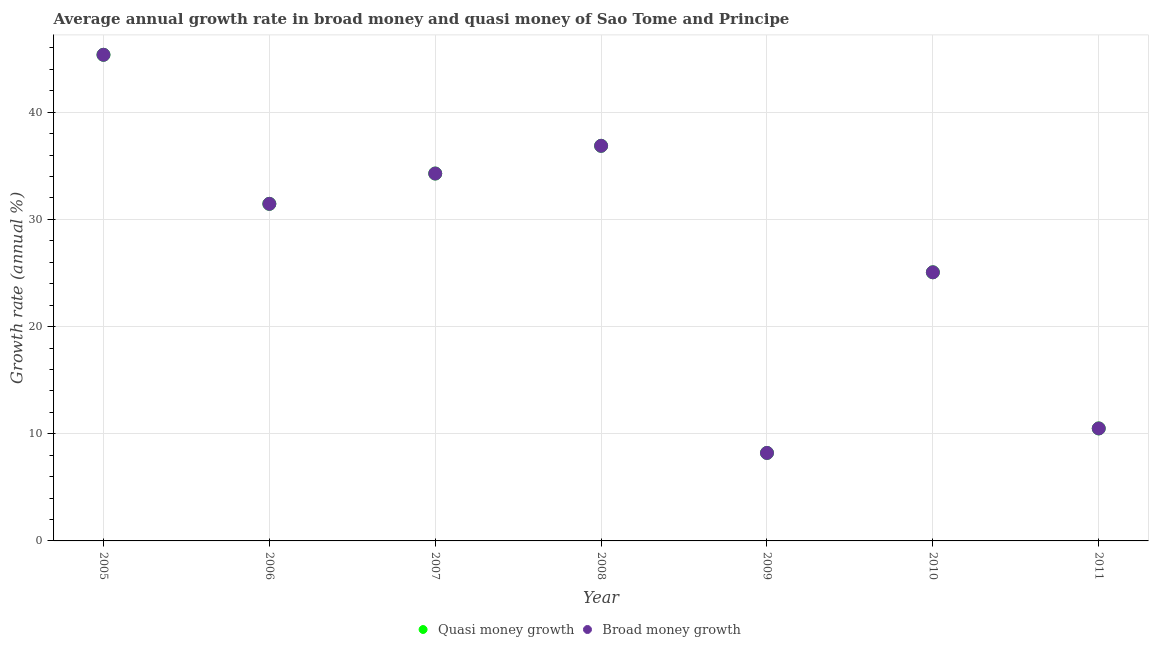Is the number of dotlines equal to the number of legend labels?
Provide a short and direct response. Yes. What is the annual growth rate in broad money in 2008?
Give a very brief answer. 36.87. Across all years, what is the maximum annual growth rate in broad money?
Keep it short and to the point. 45.36. Across all years, what is the minimum annual growth rate in quasi money?
Ensure brevity in your answer.  8.21. What is the total annual growth rate in quasi money in the graph?
Keep it short and to the point. 191.73. What is the difference between the annual growth rate in quasi money in 2006 and that in 2007?
Your answer should be very brief. -2.83. What is the difference between the annual growth rate in quasi money in 2009 and the annual growth rate in broad money in 2008?
Offer a terse response. -28.66. What is the average annual growth rate in broad money per year?
Ensure brevity in your answer.  27.39. In the year 2011, what is the difference between the annual growth rate in broad money and annual growth rate in quasi money?
Provide a short and direct response. 0. What is the ratio of the annual growth rate in broad money in 2005 to that in 2010?
Ensure brevity in your answer.  1.81. Is the difference between the annual growth rate in broad money in 2008 and 2011 greater than the difference between the annual growth rate in quasi money in 2008 and 2011?
Your answer should be very brief. No. What is the difference between the highest and the second highest annual growth rate in broad money?
Ensure brevity in your answer.  8.49. What is the difference between the highest and the lowest annual growth rate in quasi money?
Ensure brevity in your answer.  37.15. In how many years, is the annual growth rate in broad money greater than the average annual growth rate in broad money taken over all years?
Your response must be concise. 4. Is the sum of the annual growth rate in broad money in 2007 and 2011 greater than the maximum annual growth rate in quasi money across all years?
Give a very brief answer. No. Is the annual growth rate in broad money strictly less than the annual growth rate in quasi money over the years?
Provide a succinct answer. No. How many dotlines are there?
Offer a terse response. 2. How many years are there in the graph?
Offer a terse response. 7. What is the difference between two consecutive major ticks on the Y-axis?
Make the answer very short. 10. Does the graph contain any zero values?
Provide a succinct answer. No. How many legend labels are there?
Your answer should be very brief. 2. What is the title of the graph?
Provide a short and direct response. Average annual growth rate in broad money and quasi money of Sao Tome and Principe. Does "Measles" appear as one of the legend labels in the graph?
Your response must be concise. No. What is the label or title of the X-axis?
Make the answer very short. Year. What is the label or title of the Y-axis?
Provide a succinct answer. Growth rate (annual %). What is the Growth rate (annual %) in Quasi money growth in 2005?
Your answer should be compact. 45.36. What is the Growth rate (annual %) in Broad money growth in 2005?
Ensure brevity in your answer.  45.36. What is the Growth rate (annual %) of Quasi money growth in 2006?
Provide a short and direct response. 31.45. What is the Growth rate (annual %) in Broad money growth in 2006?
Your response must be concise. 31.45. What is the Growth rate (annual %) in Quasi money growth in 2007?
Your answer should be very brief. 34.28. What is the Growth rate (annual %) of Broad money growth in 2007?
Offer a very short reply. 34.28. What is the Growth rate (annual %) of Quasi money growth in 2008?
Offer a very short reply. 36.87. What is the Growth rate (annual %) of Broad money growth in 2008?
Your response must be concise. 36.87. What is the Growth rate (annual %) in Quasi money growth in 2009?
Provide a short and direct response. 8.21. What is the Growth rate (annual %) of Broad money growth in 2009?
Offer a very short reply. 8.21. What is the Growth rate (annual %) of Quasi money growth in 2010?
Give a very brief answer. 25.06. What is the Growth rate (annual %) of Broad money growth in 2010?
Your answer should be very brief. 25.06. What is the Growth rate (annual %) of Quasi money growth in 2011?
Ensure brevity in your answer.  10.5. What is the Growth rate (annual %) of Broad money growth in 2011?
Your answer should be very brief. 10.5. Across all years, what is the maximum Growth rate (annual %) in Quasi money growth?
Provide a succinct answer. 45.36. Across all years, what is the maximum Growth rate (annual %) in Broad money growth?
Give a very brief answer. 45.36. Across all years, what is the minimum Growth rate (annual %) of Quasi money growth?
Provide a short and direct response. 8.21. Across all years, what is the minimum Growth rate (annual %) in Broad money growth?
Offer a very short reply. 8.21. What is the total Growth rate (annual %) of Quasi money growth in the graph?
Provide a succinct answer. 191.73. What is the total Growth rate (annual %) in Broad money growth in the graph?
Provide a short and direct response. 191.73. What is the difference between the Growth rate (annual %) of Quasi money growth in 2005 and that in 2006?
Your response must be concise. 13.91. What is the difference between the Growth rate (annual %) of Broad money growth in 2005 and that in 2006?
Provide a short and direct response. 13.91. What is the difference between the Growth rate (annual %) of Quasi money growth in 2005 and that in 2007?
Keep it short and to the point. 11.08. What is the difference between the Growth rate (annual %) in Broad money growth in 2005 and that in 2007?
Your answer should be compact. 11.08. What is the difference between the Growth rate (annual %) of Quasi money growth in 2005 and that in 2008?
Your answer should be very brief. 8.49. What is the difference between the Growth rate (annual %) in Broad money growth in 2005 and that in 2008?
Your response must be concise. 8.49. What is the difference between the Growth rate (annual %) of Quasi money growth in 2005 and that in 2009?
Offer a terse response. 37.15. What is the difference between the Growth rate (annual %) in Broad money growth in 2005 and that in 2009?
Your response must be concise. 37.15. What is the difference between the Growth rate (annual %) in Quasi money growth in 2005 and that in 2010?
Provide a short and direct response. 20.3. What is the difference between the Growth rate (annual %) of Broad money growth in 2005 and that in 2010?
Offer a terse response. 20.3. What is the difference between the Growth rate (annual %) of Quasi money growth in 2005 and that in 2011?
Your answer should be compact. 34.86. What is the difference between the Growth rate (annual %) in Broad money growth in 2005 and that in 2011?
Keep it short and to the point. 34.86. What is the difference between the Growth rate (annual %) in Quasi money growth in 2006 and that in 2007?
Give a very brief answer. -2.83. What is the difference between the Growth rate (annual %) in Broad money growth in 2006 and that in 2007?
Your response must be concise. -2.83. What is the difference between the Growth rate (annual %) in Quasi money growth in 2006 and that in 2008?
Ensure brevity in your answer.  -5.42. What is the difference between the Growth rate (annual %) in Broad money growth in 2006 and that in 2008?
Your answer should be very brief. -5.42. What is the difference between the Growth rate (annual %) in Quasi money growth in 2006 and that in 2009?
Your answer should be very brief. 23.24. What is the difference between the Growth rate (annual %) in Broad money growth in 2006 and that in 2009?
Keep it short and to the point. 23.24. What is the difference between the Growth rate (annual %) of Quasi money growth in 2006 and that in 2010?
Ensure brevity in your answer.  6.39. What is the difference between the Growth rate (annual %) in Broad money growth in 2006 and that in 2010?
Ensure brevity in your answer.  6.39. What is the difference between the Growth rate (annual %) in Quasi money growth in 2006 and that in 2011?
Give a very brief answer. 20.95. What is the difference between the Growth rate (annual %) in Broad money growth in 2006 and that in 2011?
Give a very brief answer. 20.95. What is the difference between the Growth rate (annual %) of Quasi money growth in 2007 and that in 2008?
Your answer should be compact. -2.59. What is the difference between the Growth rate (annual %) in Broad money growth in 2007 and that in 2008?
Your answer should be very brief. -2.59. What is the difference between the Growth rate (annual %) in Quasi money growth in 2007 and that in 2009?
Make the answer very short. 26.07. What is the difference between the Growth rate (annual %) of Broad money growth in 2007 and that in 2009?
Offer a very short reply. 26.07. What is the difference between the Growth rate (annual %) of Quasi money growth in 2007 and that in 2010?
Offer a terse response. 9.22. What is the difference between the Growth rate (annual %) of Broad money growth in 2007 and that in 2010?
Your answer should be compact. 9.22. What is the difference between the Growth rate (annual %) in Quasi money growth in 2007 and that in 2011?
Provide a succinct answer. 23.78. What is the difference between the Growth rate (annual %) in Broad money growth in 2007 and that in 2011?
Your answer should be very brief. 23.78. What is the difference between the Growth rate (annual %) of Quasi money growth in 2008 and that in 2009?
Provide a short and direct response. 28.66. What is the difference between the Growth rate (annual %) of Broad money growth in 2008 and that in 2009?
Offer a terse response. 28.66. What is the difference between the Growth rate (annual %) of Quasi money growth in 2008 and that in 2010?
Provide a succinct answer. 11.8. What is the difference between the Growth rate (annual %) of Broad money growth in 2008 and that in 2010?
Ensure brevity in your answer.  11.8. What is the difference between the Growth rate (annual %) in Quasi money growth in 2008 and that in 2011?
Your answer should be compact. 26.37. What is the difference between the Growth rate (annual %) of Broad money growth in 2008 and that in 2011?
Your answer should be very brief. 26.37. What is the difference between the Growth rate (annual %) of Quasi money growth in 2009 and that in 2010?
Your answer should be compact. -16.86. What is the difference between the Growth rate (annual %) in Broad money growth in 2009 and that in 2010?
Your answer should be very brief. -16.86. What is the difference between the Growth rate (annual %) in Quasi money growth in 2009 and that in 2011?
Make the answer very short. -2.29. What is the difference between the Growth rate (annual %) in Broad money growth in 2009 and that in 2011?
Your answer should be very brief. -2.29. What is the difference between the Growth rate (annual %) in Quasi money growth in 2010 and that in 2011?
Give a very brief answer. 14.57. What is the difference between the Growth rate (annual %) of Broad money growth in 2010 and that in 2011?
Provide a short and direct response. 14.57. What is the difference between the Growth rate (annual %) in Quasi money growth in 2005 and the Growth rate (annual %) in Broad money growth in 2006?
Your answer should be compact. 13.91. What is the difference between the Growth rate (annual %) in Quasi money growth in 2005 and the Growth rate (annual %) in Broad money growth in 2007?
Provide a succinct answer. 11.08. What is the difference between the Growth rate (annual %) of Quasi money growth in 2005 and the Growth rate (annual %) of Broad money growth in 2008?
Make the answer very short. 8.49. What is the difference between the Growth rate (annual %) in Quasi money growth in 2005 and the Growth rate (annual %) in Broad money growth in 2009?
Make the answer very short. 37.15. What is the difference between the Growth rate (annual %) in Quasi money growth in 2005 and the Growth rate (annual %) in Broad money growth in 2010?
Keep it short and to the point. 20.3. What is the difference between the Growth rate (annual %) in Quasi money growth in 2005 and the Growth rate (annual %) in Broad money growth in 2011?
Keep it short and to the point. 34.86. What is the difference between the Growth rate (annual %) in Quasi money growth in 2006 and the Growth rate (annual %) in Broad money growth in 2007?
Provide a succinct answer. -2.83. What is the difference between the Growth rate (annual %) in Quasi money growth in 2006 and the Growth rate (annual %) in Broad money growth in 2008?
Your answer should be compact. -5.42. What is the difference between the Growth rate (annual %) in Quasi money growth in 2006 and the Growth rate (annual %) in Broad money growth in 2009?
Provide a short and direct response. 23.24. What is the difference between the Growth rate (annual %) of Quasi money growth in 2006 and the Growth rate (annual %) of Broad money growth in 2010?
Give a very brief answer. 6.39. What is the difference between the Growth rate (annual %) in Quasi money growth in 2006 and the Growth rate (annual %) in Broad money growth in 2011?
Your answer should be very brief. 20.95. What is the difference between the Growth rate (annual %) in Quasi money growth in 2007 and the Growth rate (annual %) in Broad money growth in 2008?
Provide a short and direct response. -2.59. What is the difference between the Growth rate (annual %) of Quasi money growth in 2007 and the Growth rate (annual %) of Broad money growth in 2009?
Make the answer very short. 26.07. What is the difference between the Growth rate (annual %) of Quasi money growth in 2007 and the Growth rate (annual %) of Broad money growth in 2010?
Ensure brevity in your answer.  9.22. What is the difference between the Growth rate (annual %) in Quasi money growth in 2007 and the Growth rate (annual %) in Broad money growth in 2011?
Offer a terse response. 23.78. What is the difference between the Growth rate (annual %) in Quasi money growth in 2008 and the Growth rate (annual %) in Broad money growth in 2009?
Give a very brief answer. 28.66. What is the difference between the Growth rate (annual %) in Quasi money growth in 2008 and the Growth rate (annual %) in Broad money growth in 2010?
Provide a succinct answer. 11.8. What is the difference between the Growth rate (annual %) in Quasi money growth in 2008 and the Growth rate (annual %) in Broad money growth in 2011?
Offer a very short reply. 26.37. What is the difference between the Growth rate (annual %) of Quasi money growth in 2009 and the Growth rate (annual %) of Broad money growth in 2010?
Provide a short and direct response. -16.86. What is the difference between the Growth rate (annual %) in Quasi money growth in 2009 and the Growth rate (annual %) in Broad money growth in 2011?
Offer a terse response. -2.29. What is the difference between the Growth rate (annual %) in Quasi money growth in 2010 and the Growth rate (annual %) in Broad money growth in 2011?
Your answer should be very brief. 14.57. What is the average Growth rate (annual %) of Quasi money growth per year?
Keep it short and to the point. 27.39. What is the average Growth rate (annual %) of Broad money growth per year?
Ensure brevity in your answer.  27.39. In the year 2005, what is the difference between the Growth rate (annual %) in Quasi money growth and Growth rate (annual %) in Broad money growth?
Make the answer very short. 0. In the year 2010, what is the difference between the Growth rate (annual %) in Quasi money growth and Growth rate (annual %) in Broad money growth?
Make the answer very short. 0. What is the ratio of the Growth rate (annual %) in Quasi money growth in 2005 to that in 2006?
Your response must be concise. 1.44. What is the ratio of the Growth rate (annual %) of Broad money growth in 2005 to that in 2006?
Make the answer very short. 1.44. What is the ratio of the Growth rate (annual %) of Quasi money growth in 2005 to that in 2007?
Your answer should be very brief. 1.32. What is the ratio of the Growth rate (annual %) in Broad money growth in 2005 to that in 2007?
Make the answer very short. 1.32. What is the ratio of the Growth rate (annual %) in Quasi money growth in 2005 to that in 2008?
Your answer should be compact. 1.23. What is the ratio of the Growth rate (annual %) in Broad money growth in 2005 to that in 2008?
Your answer should be very brief. 1.23. What is the ratio of the Growth rate (annual %) in Quasi money growth in 2005 to that in 2009?
Offer a terse response. 5.53. What is the ratio of the Growth rate (annual %) in Broad money growth in 2005 to that in 2009?
Your answer should be very brief. 5.53. What is the ratio of the Growth rate (annual %) in Quasi money growth in 2005 to that in 2010?
Offer a very short reply. 1.81. What is the ratio of the Growth rate (annual %) in Broad money growth in 2005 to that in 2010?
Offer a very short reply. 1.81. What is the ratio of the Growth rate (annual %) of Quasi money growth in 2005 to that in 2011?
Make the answer very short. 4.32. What is the ratio of the Growth rate (annual %) in Broad money growth in 2005 to that in 2011?
Ensure brevity in your answer.  4.32. What is the ratio of the Growth rate (annual %) of Quasi money growth in 2006 to that in 2007?
Provide a succinct answer. 0.92. What is the ratio of the Growth rate (annual %) in Broad money growth in 2006 to that in 2007?
Your response must be concise. 0.92. What is the ratio of the Growth rate (annual %) in Quasi money growth in 2006 to that in 2008?
Ensure brevity in your answer.  0.85. What is the ratio of the Growth rate (annual %) in Broad money growth in 2006 to that in 2008?
Your answer should be compact. 0.85. What is the ratio of the Growth rate (annual %) in Quasi money growth in 2006 to that in 2009?
Give a very brief answer. 3.83. What is the ratio of the Growth rate (annual %) of Broad money growth in 2006 to that in 2009?
Provide a succinct answer. 3.83. What is the ratio of the Growth rate (annual %) in Quasi money growth in 2006 to that in 2010?
Your answer should be compact. 1.25. What is the ratio of the Growth rate (annual %) of Broad money growth in 2006 to that in 2010?
Keep it short and to the point. 1.25. What is the ratio of the Growth rate (annual %) in Quasi money growth in 2006 to that in 2011?
Offer a very short reply. 3. What is the ratio of the Growth rate (annual %) in Broad money growth in 2006 to that in 2011?
Provide a succinct answer. 3. What is the ratio of the Growth rate (annual %) in Quasi money growth in 2007 to that in 2008?
Your answer should be very brief. 0.93. What is the ratio of the Growth rate (annual %) in Broad money growth in 2007 to that in 2008?
Your response must be concise. 0.93. What is the ratio of the Growth rate (annual %) of Quasi money growth in 2007 to that in 2009?
Provide a short and direct response. 4.18. What is the ratio of the Growth rate (annual %) of Broad money growth in 2007 to that in 2009?
Keep it short and to the point. 4.18. What is the ratio of the Growth rate (annual %) of Quasi money growth in 2007 to that in 2010?
Ensure brevity in your answer.  1.37. What is the ratio of the Growth rate (annual %) of Broad money growth in 2007 to that in 2010?
Your answer should be very brief. 1.37. What is the ratio of the Growth rate (annual %) in Quasi money growth in 2007 to that in 2011?
Offer a terse response. 3.27. What is the ratio of the Growth rate (annual %) of Broad money growth in 2007 to that in 2011?
Your answer should be very brief. 3.27. What is the ratio of the Growth rate (annual %) in Quasi money growth in 2008 to that in 2009?
Your response must be concise. 4.49. What is the ratio of the Growth rate (annual %) in Broad money growth in 2008 to that in 2009?
Ensure brevity in your answer.  4.49. What is the ratio of the Growth rate (annual %) in Quasi money growth in 2008 to that in 2010?
Your response must be concise. 1.47. What is the ratio of the Growth rate (annual %) of Broad money growth in 2008 to that in 2010?
Offer a very short reply. 1.47. What is the ratio of the Growth rate (annual %) in Quasi money growth in 2008 to that in 2011?
Offer a terse response. 3.51. What is the ratio of the Growth rate (annual %) in Broad money growth in 2008 to that in 2011?
Keep it short and to the point. 3.51. What is the ratio of the Growth rate (annual %) of Quasi money growth in 2009 to that in 2010?
Ensure brevity in your answer.  0.33. What is the ratio of the Growth rate (annual %) of Broad money growth in 2009 to that in 2010?
Your response must be concise. 0.33. What is the ratio of the Growth rate (annual %) of Quasi money growth in 2009 to that in 2011?
Offer a very short reply. 0.78. What is the ratio of the Growth rate (annual %) in Broad money growth in 2009 to that in 2011?
Give a very brief answer. 0.78. What is the ratio of the Growth rate (annual %) in Quasi money growth in 2010 to that in 2011?
Your answer should be very brief. 2.39. What is the ratio of the Growth rate (annual %) in Broad money growth in 2010 to that in 2011?
Offer a very short reply. 2.39. What is the difference between the highest and the second highest Growth rate (annual %) of Quasi money growth?
Keep it short and to the point. 8.49. What is the difference between the highest and the second highest Growth rate (annual %) of Broad money growth?
Your answer should be compact. 8.49. What is the difference between the highest and the lowest Growth rate (annual %) in Quasi money growth?
Make the answer very short. 37.15. What is the difference between the highest and the lowest Growth rate (annual %) of Broad money growth?
Offer a terse response. 37.15. 